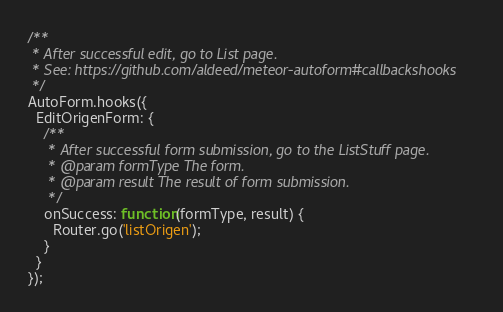Convert code to text. <code><loc_0><loc_0><loc_500><loc_500><_JavaScript_>/**
 * After successful edit, go to List page.
 * See: https://github.com/aldeed/meteor-autoform#callbackshooks
 */
AutoForm.hooks({
  EditOrigenForm: {
    /**
     * After successful form submission, go to the ListStuff page.
     * @param formType The form.
     * @param result The result of form submission.
     */
    onSuccess: function(formType, result) {
      Router.go('listOrigen');
    }
  }
});</code> 